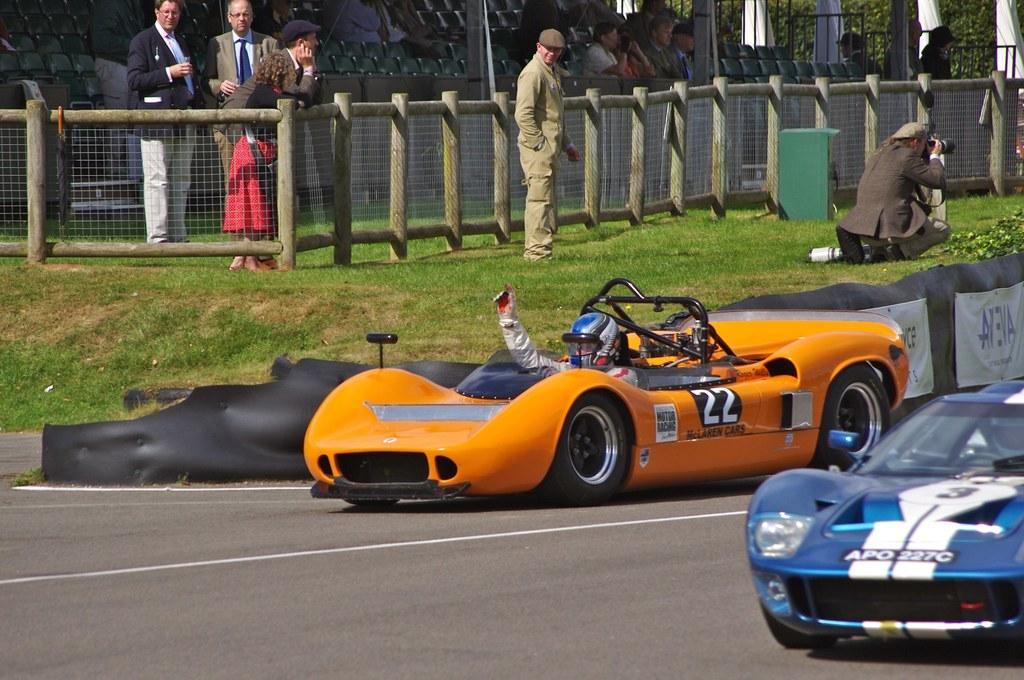How many cars are visible in the image? There are two cars in the image. What are the people in the image doing? Some people are standing and watching the cars, while others are seated on chairs in the background. Who is taking photographs in the image? A man is taking photographs using a camera. What type of plant is growing in the image? There is no plant visible in the image. What effect does the yam have on the people in the image? There is no yam present in the image, so it cannot have any effect on the people. 